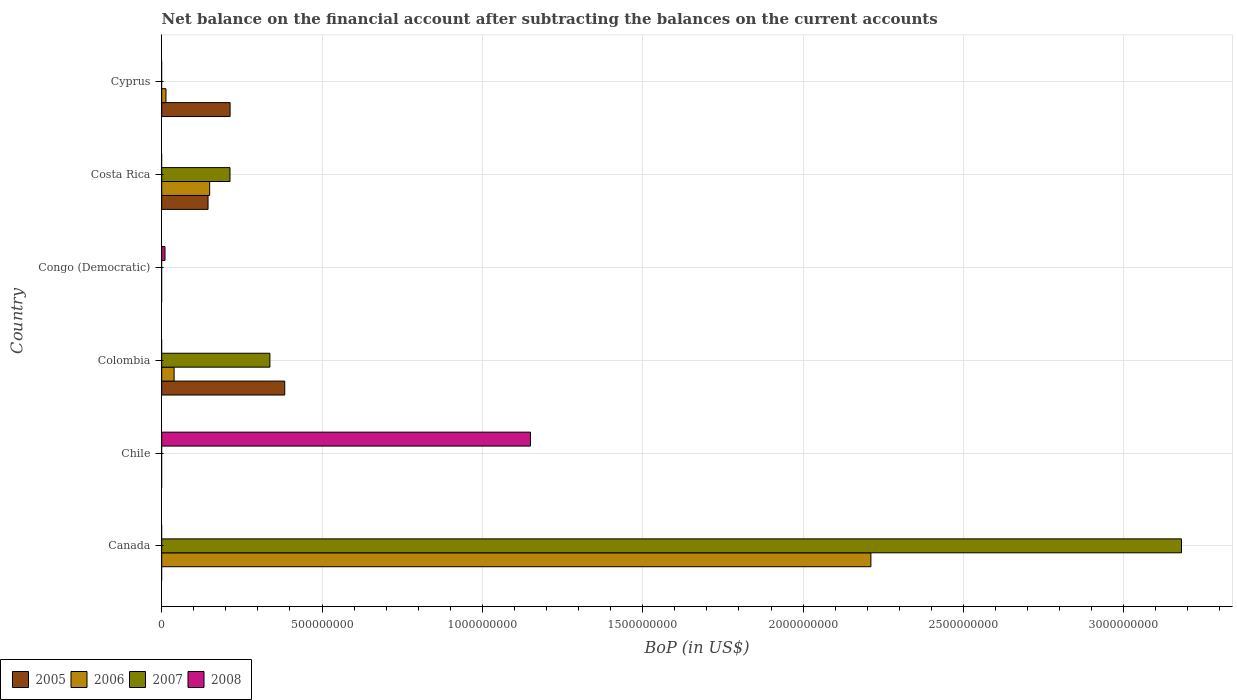How many different coloured bars are there?
Ensure brevity in your answer.  4. Are the number of bars per tick equal to the number of legend labels?
Provide a short and direct response. No. How many bars are there on the 1st tick from the bottom?
Your answer should be compact. 2. What is the label of the 4th group of bars from the top?
Give a very brief answer. Colombia. In how many cases, is the number of bars for a given country not equal to the number of legend labels?
Provide a succinct answer. 6. Across all countries, what is the maximum Balance of Payments in 2006?
Keep it short and to the point. 2.21e+09. Across all countries, what is the minimum Balance of Payments in 2005?
Offer a very short reply. 0. What is the total Balance of Payments in 2008 in the graph?
Keep it short and to the point. 1.16e+09. What is the difference between the Balance of Payments in 2008 in Chile and that in Congo (Democratic)?
Offer a very short reply. 1.14e+09. What is the average Balance of Payments in 2008 per country?
Provide a succinct answer. 1.93e+08. What is the difference between the Balance of Payments in 2007 and Balance of Payments in 2005 in Costa Rica?
Offer a terse response. 6.85e+07. In how many countries, is the Balance of Payments in 2005 greater than 2300000000 US$?
Provide a succinct answer. 0. What is the ratio of the Balance of Payments in 2007 in Canada to that in Colombia?
Your answer should be very brief. 9.43. What is the difference between the highest and the second highest Balance of Payments in 2005?
Your response must be concise. 1.70e+08. What is the difference between the highest and the lowest Balance of Payments in 2008?
Provide a short and direct response. 1.15e+09. Is it the case that in every country, the sum of the Balance of Payments in 2005 and Balance of Payments in 2006 is greater than the sum of Balance of Payments in 2008 and Balance of Payments in 2007?
Your answer should be compact. No. Is it the case that in every country, the sum of the Balance of Payments in 2005 and Balance of Payments in 2006 is greater than the Balance of Payments in 2007?
Make the answer very short. No. How many bars are there?
Your response must be concise. 12. Are all the bars in the graph horizontal?
Offer a very short reply. Yes. How many countries are there in the graph?
Give a very brief answer. 6. Does the graph contain any zero values?
Your response must be concise. Yes. What is the title of the graph?
Offer a terse response. Net balance on the financial account after subtracting the balances on the current accounts. What is the label or title of the X-axis?
Offer a very short reply. BoP (in US$). What is the BoP (in US$) in 2005 in Canada?
Offer a terse response. 0. What is the BoP (in US$) of 2006 in Canada?
Provide a short and direct response. 2.21e+09. What is the BoP (in US$) of 2007 in Canada?
Make the answer very short. 3.18e+09. What is the BoP (in US$) in 2008 in Canada?
Your answer should be compact. 0. What is the BoP (in US$) of 2005 in Chile?
Your response must be concise. 0. What is the BoP (in US$) in 2006 in Chile?
Offer a very short reply. 0. What is the BoP (in US$) of 2008 in Chile?
Your answer should be very brief. 1.15e+09. What is the BoP (in US$) in 2005 in Colombia?
Give a very brief answer. 3.84e+08. What is the BoP (in US$) of 2006 in Colombia?
Offer a very short reply. 3.87e+07. What is the BoP (in US$) of 2007 in Colombia?
Your answer should be compact. 3.37e+08. What is the BoP (in US$) of 2008 in Congo (Democratic)?
Give a very brief answer. 1.03e+07. What is the BoP (in US$) in 2005 in Costa Rica?
Offer a very short reply. 1.44e+08. What is the BoP (in US$) in 2006 in Costa Rica?
Provide a succinct answer. 1.50e+08. What is the BoP (in US$) of 2007 in Costa Rica?
Your response must be concise. 2.13e+08. What is the BoP (in US$) of 2005 in Cyprus?
Make the answer very short. 2.13e+08. What is the BoP (in US$) in 2006 in Cyprus?
Your answer should be very brief. 1.33e+07. What is the BoP (in US$) of 2008 in Cyprus?
Offer a very short reply. 0. Across all countries, what is the maximum BoP (in US$) in 2005?
Offer a very short reply. 3.84e+08. Across all countries, what is the maximum BoP (in US$) of 2006?
Ensure brevity in your answer.  2.21e+09. Across all countries, what is the maximum BoP (in US$) of 2007?
Keep it short and to the point. 3.18e+09. Across all countries, what is the maximum BoP (in US$) in 2008?
Give a very brief answer. 1.15e+09. Across all countries, what is the minimum BoP (in US$) in 2005?
Make the answer very short. 0. Across all countries, what is the minimum BoP (in US$) of 2008?
Provide a short and direct response. 0. What is the total BoP (in US$) in 2005 in the graph?
Give a very brief answer. 7.41e+08. What is the total BoP (in US$) in 2006 in the graph?
Your answer should be very brief. 2.41e+09. What is the total BoP (in US$) of 2007 in the graph?
Keep it short and to the point. 3.73e+09. What is the total BoP (in US$) of 2008 in the graph?
Your response must be concise. 1.16e+09. What is the difference between the BoP (in US$) of 2006 in Canada and that in Colombia?
Provide a short and direct response. 2.17e+09. What is the difference between the BoP (in US$) in 2007 in Canada and that in Colombia?
Keep it short and to the point. 2.84e+09. What is the difference between the BoP (in US$) of 2006 in Canada and that in Costa Rica?
Make the answer very short. 2.06e+09. What is the difference between the BoP (in US$) in 2007 in Canada and that in Costa Rica?
Provide a succinct answer. 2.97e+09. What is the difference between the BoP (in US$) in 2006 in Canada and that in Cyprus?
Offer a very short reply. 2.20e+09. What is the difference between the BoP (in US$) of 2008 in Chile and that in Congo (Democratic)?
Give a very brief answer. 1.14e+09. What is the difference between the BoP (in US$) of 2005 in Colombia and that in Costa Rica?
Keep it short and to the point. 2.39e+08. What is the difference between the BoP (in US$) of 2006 in Colombia and that in Costa Rica?
Offer a terse response. -1.11e+08. What is the difference between the BoP (in US$) in 2007 in Colombia and that in Costa Rica?
Your answer should be very brief. 1.24e+08. What is the difference between the BoP (in US$) of 2005 in Colombia and that in Cyprus?
Your response must be concise. 1.70e+08. What is the difference between the BoP (in US$) in 2006 in Colombia and that in Cyprus?
Offer a very short reply. 2.53e+07. What is the difference between the BoP (in US$) of 2005 in Costa Rica and that in Cyprus?
Provide a short and direct response. -6.87e+07. What is the difference between the BoP (in US$) of 2006 in Costa Rica and that in Cyprus?
Keep it short and to the point. 1.36e+08. What is the difference between the BoP (in US$) of 2006 in Canada and the BoP (in US$) of 2008 in Chile?
Provide a short and direct response. 1.06e+09. What is the difference between the BoP (in US$) of 2007 in Canada and the BoP (in US$) of 2008 in Chile?
Keep it short and to the point. 2.03e+09. What is the difference between the BoP (in US$) of 2006 in Canada and the BoP (in US$) of 2007 in Colombia?
Your response must be concise. 1.87e+09. What is the difference between the BoP (in US$) in 2006 in Canada and the BoP (in US$) in 2008 in Congo (Democratic)?
Provide a short and direct response. 2.20e+09. What is the difference between the BoP (in US$) in 2007 in Canada and the BoP (in US$) in 2008 in Congo (Democratic)?
Your answer should be very brief. 3.17e+09. What is the difference between the BoP (in US$) in 2006 in Canada and the BoP (in US$) in 2007 in Costa Rica?
Keep it short and to the point. 2.00e+09. What is the difference between the BoP (in US$) in 2005 in Colombia and the BoP (in US$) in 2008 in Congo (Democratic)?
Offer a very short reply. 3.73e+08. What is the difference between the BoP (in US$) of 2006 in Colombia and the BoP (in US$) of 2008 in Congo (Democratic)?
Keep it short and to the point. 2.84e+07. What is the difference between the BoP (in US$) of 2007 in Colombia and the BoP (in US$) of 2008 in Congo (Democratic)?
Provide a short and direct response. 3.27e+08. What is the difference between the BoP (in US$) in 2005 in Colombia and the BoP (in US$) in 2006 in Costa Rica?
Ensure brevity in your answer.  2.34e+08. What is the difference between the BoP (in US$) in 2005 in Colombia and the BoP (in US$) in 2007 in Costa Rica?
Your response must be concise. 1.71e+08. What is the difference between the BoP (in US$) of 2006 in Colombia and the BoP (in US$) of 2007 in Costa Rica?
Your response must be concise. -1.74e+08. What is the difference between the BoP (in US$) in 2005 in Colombia and the BoP (in US$) in 2006 in Cyprus?
Your response must be concise. 3.70e+08. What is the difference between the BoP (in US$) of 2005 in Costa Rica and the BoP (in US$) of 2006 in Cyprus?
Your answer should be very brief. 1.31e+08. What is the average BoP (in US$) of 2005 per country?
Provide a succinct answer. 1.24e+08. What is the average BoP (in US$) in 2006 per country?
Provide a succinct answer. 4.02e+08. What is the average BoP (in US$) in 2007 per country?
Provide a succinct answer. 6.22e+08. What is the average BoP (in US$) of 2008 per country?
Ensure brevity in your answer.  1.93e+08. What is the difference between the BoP (in US$) in 2006 and BoP (in US$) in 2007 in Canada?
Give a very brief answer. -9.69e+08. What is the difference between the BoP (in US$) of 2005 and BoP (in US$) of 2006 in Colombia?
Offer a very short reply. 3.45e+08. What is the difference between the BoP (in US$) in 2005 and BoP (in US$) in 2007 in Colombia?
Your response must be concise. 4.63e+07. What is the difference between the BoP (in US$) of 2006 and BoP (in US$) of 2007 in Colombia?
Your response must be concise. -2.99e+08. What is the difference between the BoP (in US$) of 2005 and BoP (in US$) of 2006 in Costa Rica?
Your response must be concise. -5.05e+06. What is the difference between the BoP (in US$) in 2005 and BoP (in US$) in 2007 in Costa Rica?
Keep it short and to the point. -6.85e+07. What is the difference between the BoP (in US$) in 2006 and BoP (in US$) in 2007 in Costa Rica?
Offer a very short reply. -6.34e+07. What is the difference between the BoP (in US$) in 2005 and BoP (in US$) in 2006 in Cyprus?
Your answer should be compact. 2.00e+08. What is the ratio of the BoP (in US$) in 2006 in Canada to that in Colombia?
Your response must be concise. 57.22. What is the ratio of the BoP (in US$) in 2007 in Canada to that in Colombia?
Your answer should be compact. 9.43. What is the ratio of the BoP (in US$) in 2006 in Canada to that in Costa Rica?
Offer a very short reply. 14.79. What is the ratio of the BoP (in US$) in 2007 in Canada to that in Costa Rica?
Provide a succinct answer. 14.93. What is the ratio of the BoP (in US$) of 2006 in Canada to that in Cyprus?
Provide a succinct answer. 165.78. What is the ratio of the BoP (in US$) in 2008 in Chile to that in Congo (Democratic)?
Provide a short and direct response. 111.64. What is the ratio of the BoP (in US$) in 2005 in Colombia to that in Costa Rica?
Ensure brevity in your answer.  2.66. What is the ratio of the BoP (in US$) of 2006 in Colombia to that in Costa Rica?
Provide a succinct answer. 0.26. What is the ratio of the BoP (in US$) of 2007 in Colombia to that in Costa Rica?
Ensure brevity in your answer.  1.58. What is the ratio of the BoP (in US$) of 2005 in Colombia to that in Cyprus?
Give a very brief answer. 1.8. What is the ratio of the BoP (in US$) of 2006 in Colombia to that in Cyprus?
Give a very brief answer. 2.9. What is the ratio of the BoP (in US$) in 2005 in Costa Rica to that in Cyprus?
Ensure brevity in your answer.  0.68. What is the ratio of the BoP (in US$) in 2006 in Costa Rica to that in Cyprus?
Ensure brevity in your answer.  11.21. What is the difference between the highest and the second highest BoP (in US$) in 2005?
Keep it short and to the point. 1.70e+08. What is the difference between the highest and the second highest BoP (in US$) of 2006?
Your answer should be very brief. 2.06e+09. What is the difference between the highest and the second highest BoP (in US$) in 2007?
Make the answer very short. 2.84e+09. What is the difference between the highest and the lowest BoP (in US$) in 2005?
Make the answer very short. 3.84e+08. What is the difference between the highest and the lowest BoP (in US$) in 2006?
Offer a terse response. 2.21e+09. What is the difference between the highest and the lowest BoP (in US$) of 2007?
Your response must be concise. 3.18e+09. What is the difference between the highest and the lowest BoP (in US$) in 2008?
Offer a terse response. 1.15e+09. 